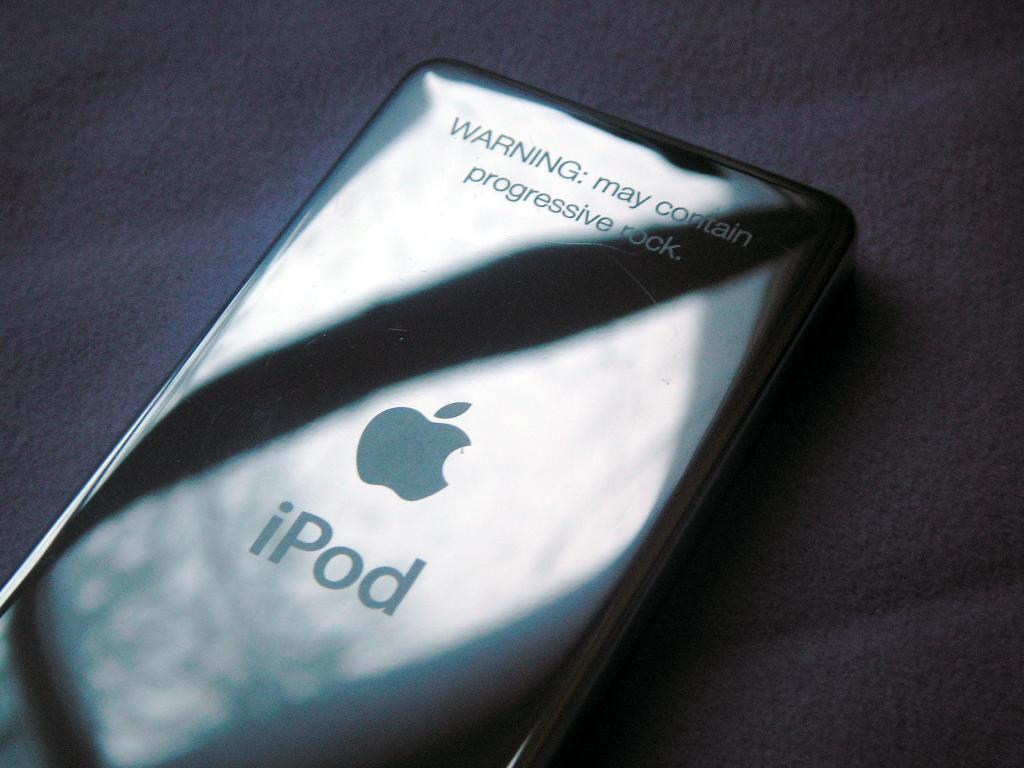What electronic device is visible in the image? There is an iPod in the image. Where is the iPod located in the image? The iPod is placed on a surface. What type of bone is visible in the image? There is no bone present in the image; it only features an iPod placed on a surface. 